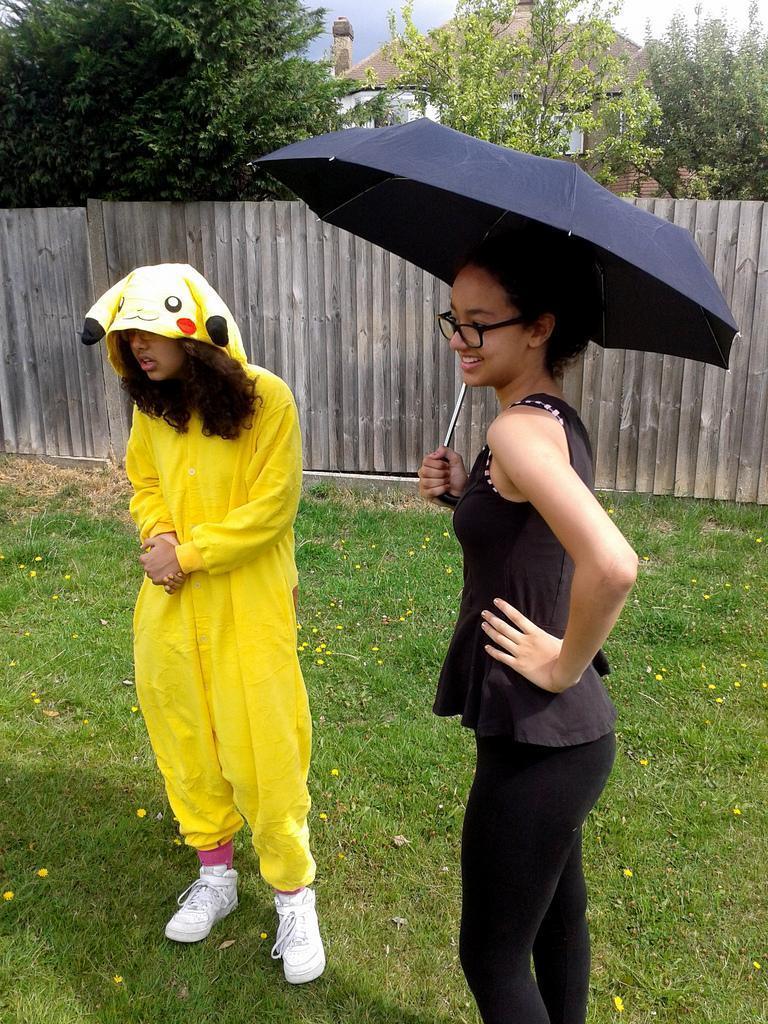How many people are shown?
Give a very brief answer. 2. How many total trees are shown behind the fence and in the background?
Give a very brief answer. 3. 